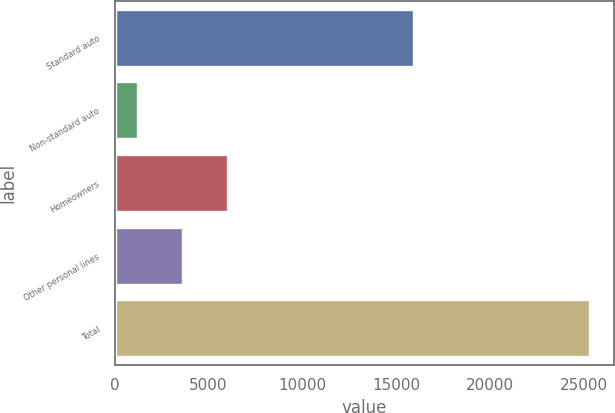Convert chart. <chart><loc_0><loc_0><loc_500><loc_500><bar_chart><fcel>Standard auto<fcel>Non-standard auto<fcel>Homeowners<fcel>Other personal lines<fcel>Total<nl><fcel>15952<fcel>1232<fcel>6054<fcel>3643<fcel>25342<nl></chart> 